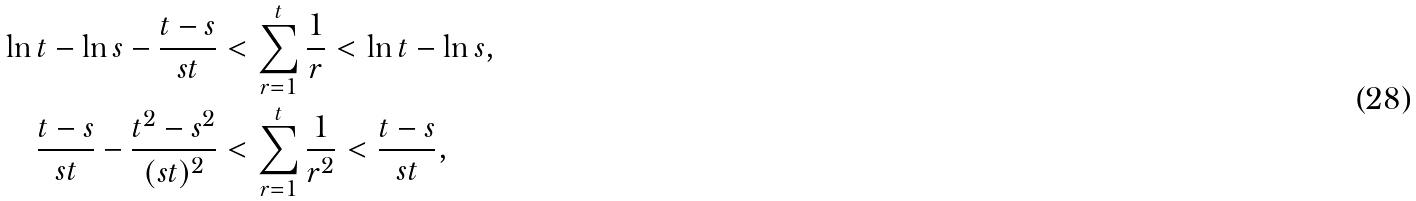Convert formula to latex. <formula><loc_0><loc_0><loc_500><loc_500>\ln t - \ln s - \frac { t - s } { s t } & < \sum _ { r = 1 } ^ { t } \frac { 1 } { r } < \ln t - \ln s , \\ \frac { t - s } { s t } - \frac { t ^ { 2 } - s ^ { 2 } } { ( s t ) ^ { 2 } } & < \sum _ { r = 1 } ^ { t } \frac { 1 } { r ^ { 2 } } < \frac { t - s } { s t } ,</formula> 